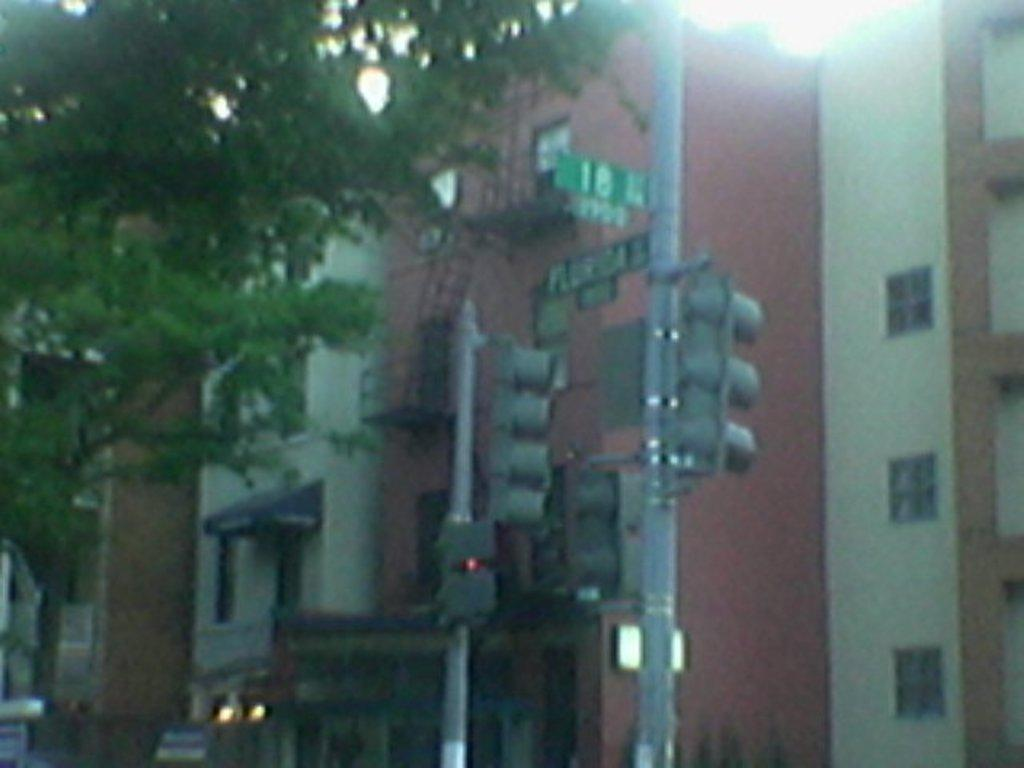What type of structures can be seen in the image? There are buildings in the image. What is located in front of the buildings? There are two traffic signal poles in front of the buildings. What type of vegetation is on the left side of the image? There is a tree on the left side of the image. How many girls are using the tree as a slip in the image? There are no girls present in the image, and the tree is not being used as a slip. 